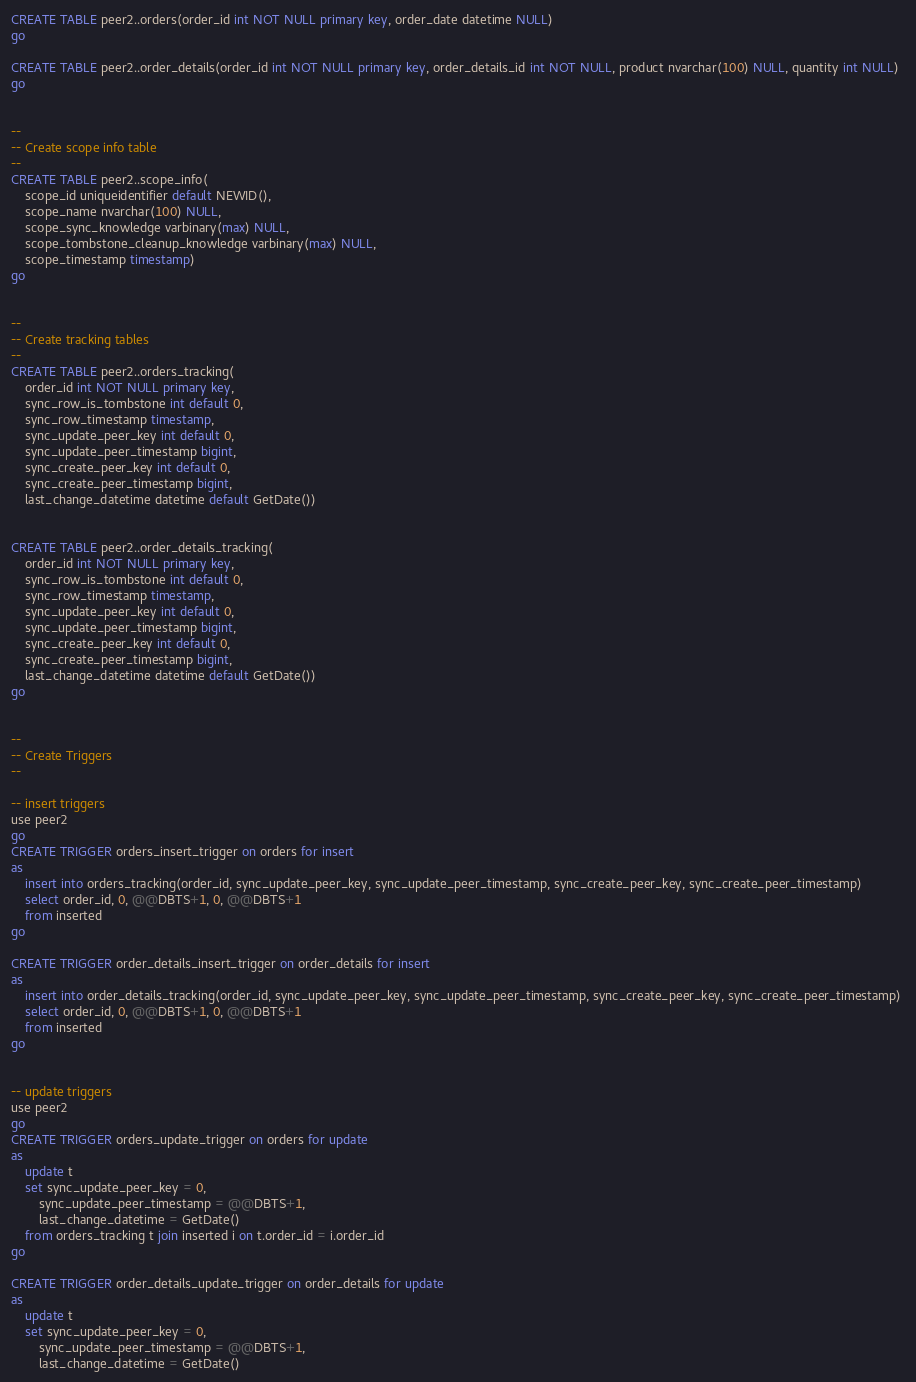Convert code to text. <code><loc_0><loc_0><loc_500><loc_500><_SQL_>

CREATE TABLE peer2..orders(order_id int NOT NULL primary key, order_date datetime NULL)
go

CREATE TABLE peer2..order_details(order_id int NOT NULL primary key, order_details_id int NOT NULL, product nvarchar(100) NULL, quantity int NULL)
go


--
-- Create scope info table
--
CREATE TABLE peer2..scope_info(    	
    scope_id uniqueidentifier default NEWID(), 	
    scope_name nvarchar(100) NULL,
    scope_sync_knowledge varbinary(max) NULL,
	scope_tombstone_cleanup_knowledge varbinary(max) NULL,
	scope_timestamp timestamp)
go


--
-- Create tracking tables
--
CREATE TABLE peer2..orders_tracking(
    order_id int NOT NULL primary key,          
    sync_row_is_tombstone int default 0,
    sync_row_timestamp timestamp, 
    sync_update_peer_key int default 0,
    sync_update_peer_timestamp bigint,        
    sync_create_peer_key int default 0,
    sync_create_peer_timestamp bigint,
	last_change_datetime datetime default GetDate())


CREATE TABLE peer2..order_details_tracking(
    order_id int NOT NULL primary key,         
    sync_row_is_tombstone int default 0,
    sync_row_timestamp timestamp, 
    sync_update_peer_key int default 0,
    sync_update_peer_timestamp bigint,        
    sync_create_peer_key int default 0,
    sync_create_peer_timestamp bigint,
	last_change_datetime datetime default GetDate())
go
     

-- 
-- Create Triggers
--

-- insert triggers
use peer2
go
CREATE TRIGGER orders_insert_trigger on orders for insert
as    
	insert into orders_tracking(order_id, sync_update_peer_key, sync_update_peer_timestamp, sync_create_peer_key, sync_create_peer_timestamp) 
	select order_id, 0, @@DBTS+1, 0, @@DBTS+1
	from inserted		
go

CREATE TRIGGER order_details_insert_trigger on order_details for insert
as
    insert into order_details_tracking(order_id, sync_update_peer_key, sync_update_peer_timestamp, sync_create_peer_key, sync_create_peer_timestamp) 
	select order_id, 0, @@DBTS+1, 0, @@DBTS+1
	from inserted		
go


-- update triggers
use peer2
go
CREATE TRIGGER orders_update_trigger on orders for update
as    
    update t    
	set sync_update_peer_key = 0, 
		sync_update_peer_timestamp = @@DBTS+1,
	    last_change_datetime = GetDate()
	from orders_tracking t join inserted i on t.order_id = i.order_id     	
go

CREATE TRIGGER order_details_update_trigger on order_details for update
as
    update t    
	set sync_update_peer_key = 0, 
		sync_update_peer_timestamp = @@DBTS+1,
	    last_change_datetime = GetDate()</code> 